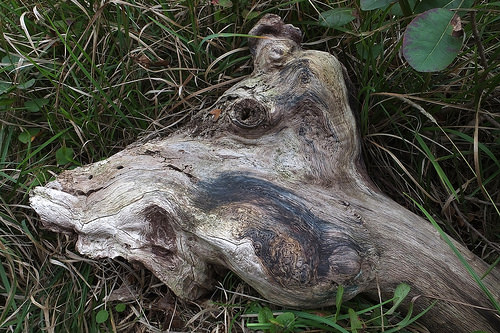<image>
Is there a grass next to the log? Yes. The grass is positioned adjacent to the log, located nearby in the same general area. 